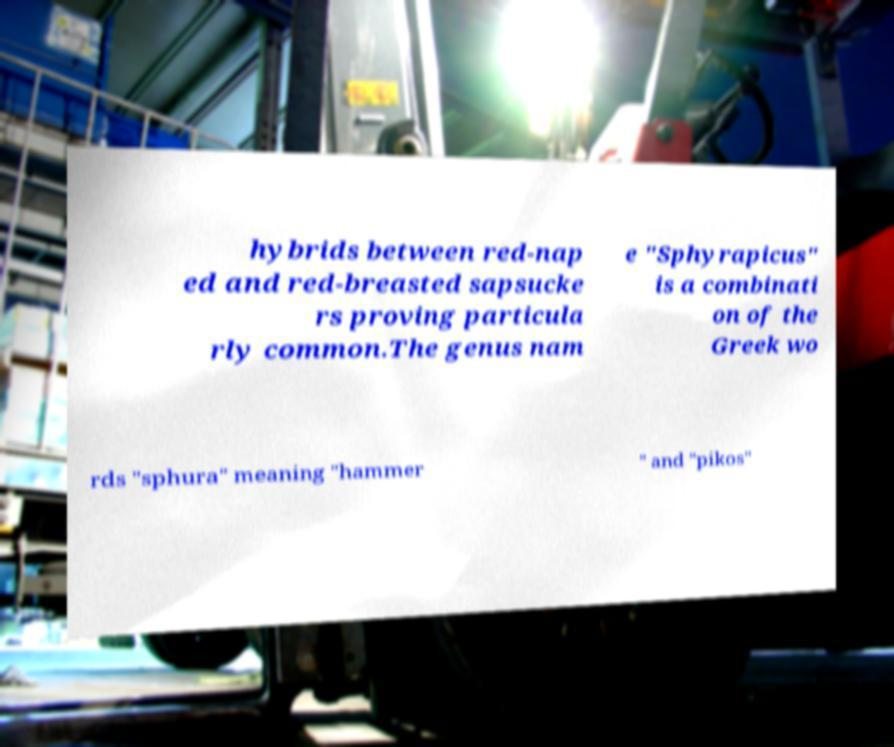Could you extract and type out the text from this image? hybrids between red-nap ed and red-breasted sapsucke rs proving particula rly common.The genus nam e "Sphyrapicus" is a combinati on of the Greek wo rds "sphura" meaning "hammer " and "pikos" 